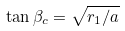Convert formula to latex. <formula><loc_0><loc_0><loc_500><loc_500>\tan \beta _ { c } = \sqrt { r _ { 1 } / a }</formula> 